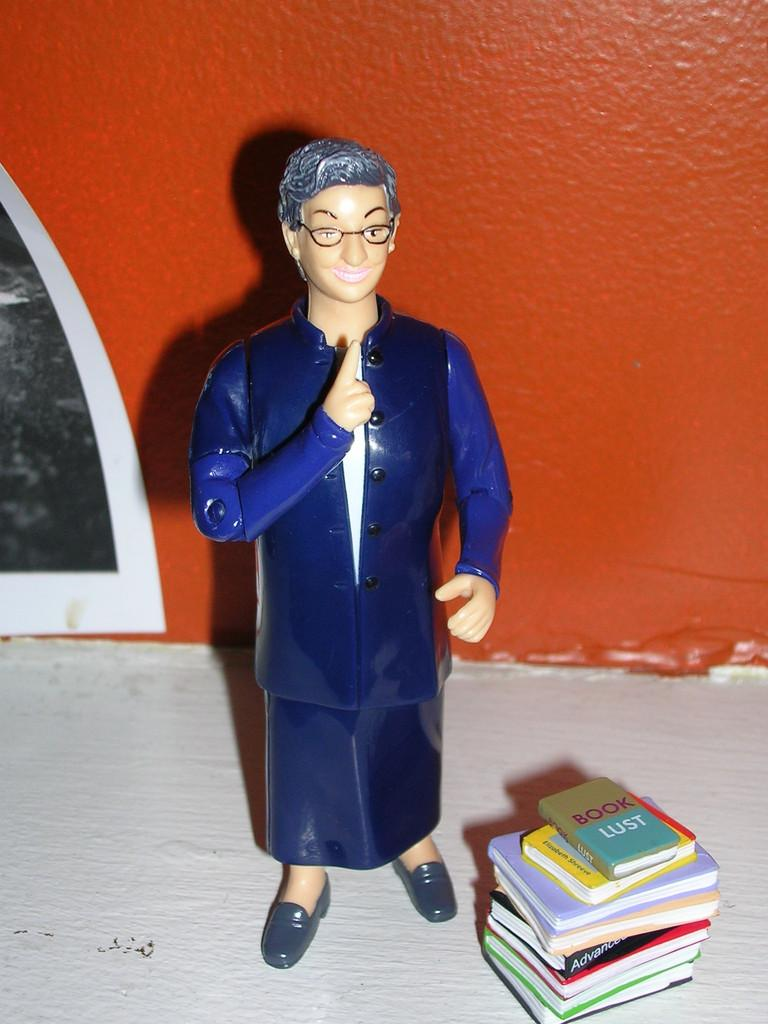What object can be seen in the image? There is a toy in the image. Where is the toy located in relation to other objects? The toy is in front of a wall. What else can be seen in the bottom right of the image? There are books in the bottom right of the image. How many geese are shaking hands with the porter in the image? There are no geese or porters present in the image. 